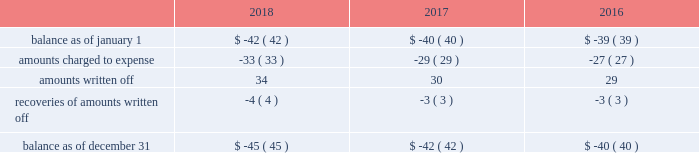Note 6 : allowance for uncollectible accounts the table provides the changes in the allowances for uncollectible accounts for the years ended december 31: .
Note 7 : regulatory assets and liabilities regulatory assets regulatory assets represent costs that are probable of recovery from customers in future rates .
The majority of the regulatory assets earn a return .
The following table provides the composition of regulatory assets as of december 31 : 2018 2017 deferred pension expense .
$ 362 $ 285 removal costs recoverable through rates .
292 269 regulatory balancing accounts .
110 113 san clemente dam project costs .
85 89 debt expense .
70 67 purchase premium recoverable through rates .
56 57 deferred tank painting costs .
42 42 make-whole premium on early extinguishment of debt .
33 27 other .
106 112 total regulatory assets .
$ 1156 $ 1061 the company 2019s deferred pension expense includes a portion of the underfunded status that is probable of recovery through rates in future periods of $ 352 million and $ 270 million as of december 31 , 2018 and 2017 , respectively .
The remaining portion is the pension expense in excess of the amount contributed to the pension plans which is deferred by certain subsidiaries and will be recovered in future service rates as contributions are made to the pension plan .
Removal costs recoverable through rates represent costs incurred for removal of property , plant and equipment or other retirement costs .
Regulatory balancing accounts accumulate differences between revenues recognized and authorized revenue requirements until they are collected from customers or are refunded .
Regulatory balancing accounts include low income programs and purchased power and water accounts .
San clemente dam project costs represent costs incurred and deferred by the company 2019s utility subsidiary in california pursuant to its efforts to investigate alternatives and remove the dam due to potential earthquake and flood safety concerns .
In june 2012 , the california public utilities commission ( 201ccpuc 201d ) issued a decision authorizing implementation of a project to reroute the carmel river and remove the san clemente dam .
The project includes the company 2019s utility subsidiary in california , the california state conservancy and the national marine fisheries services .
Under the order 2019s terms , the cpuc has authorized recovery for .
What was total amounts written off for the three years? 
Computations: table_sum(amounts written off, none)
Answer: 93.0. 